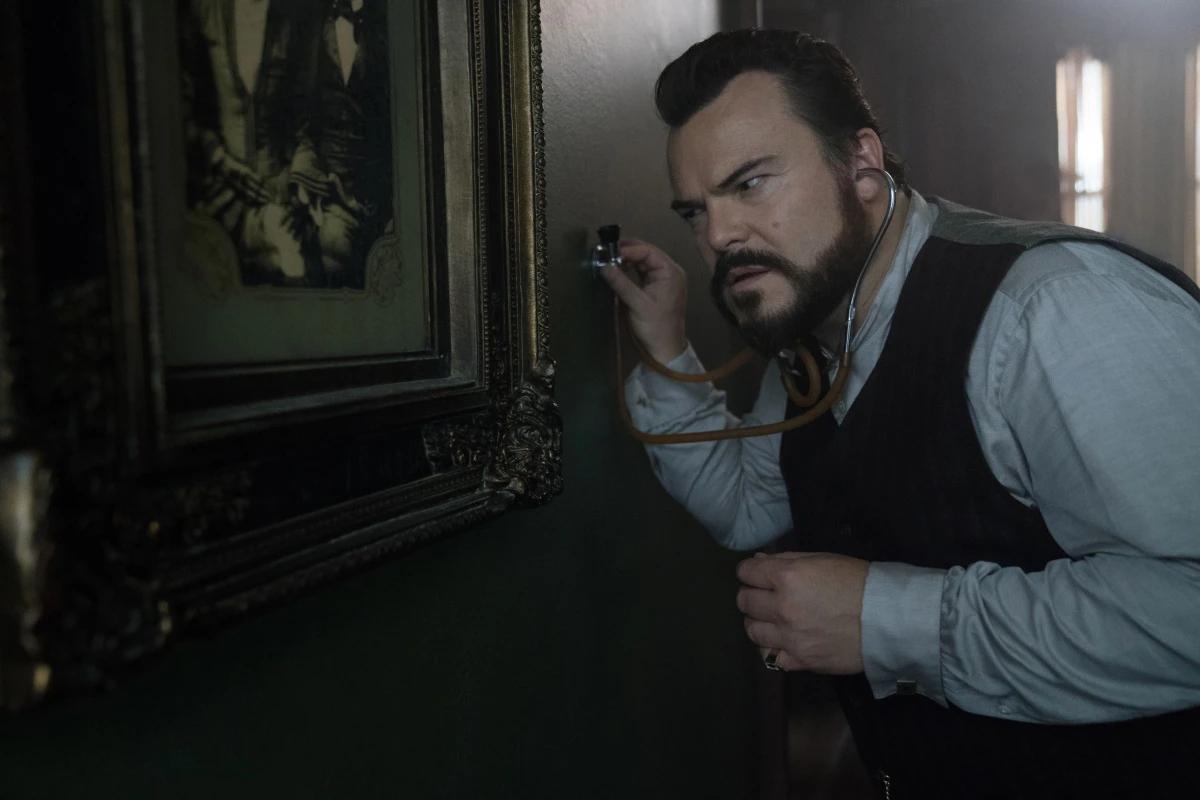Imagine a fantastical twist to this scenario. What's happening here in a magical world? In a magical world, this character is a renowned wizard-detective named Arcanus Whisperwind. The stethoscope is enchanted, allowing him to hear whispers from the past. The old painting is a portal to another dimension, and he is eavesdropping on the conversations of long-gone sorcerers who left clues about a hidden treasure. The walls of this enchanted room are alive, murmuring secrets as he listens. The air is thick with ancient spells, and the window beside him shows glimpses of a mystical forest where mythical creatures roam. This scene is part of a grand adventure to unlock the mysteries of an ancient realm. What do you think Arcanus Whisperwind will discover next? Arcanus Whisperwind will soon discover that the whispers from the painting are leading him to an ancient grimoire hidden within the walls of this very room. This grimoire holds powerful spells and the secrets to defeating the malevolent spirit that has been haunting the magical realm. As he pieces together the clues, he will find a hidden compartment that can only be opened with a spell known by heart to the first Whisperwind. Inside, the grimoire will reveal a map of the forbidden forest, guiding him to the Dragon's Lair, where the ultimate confrontation between good and evil will determine the fate of the realm. 